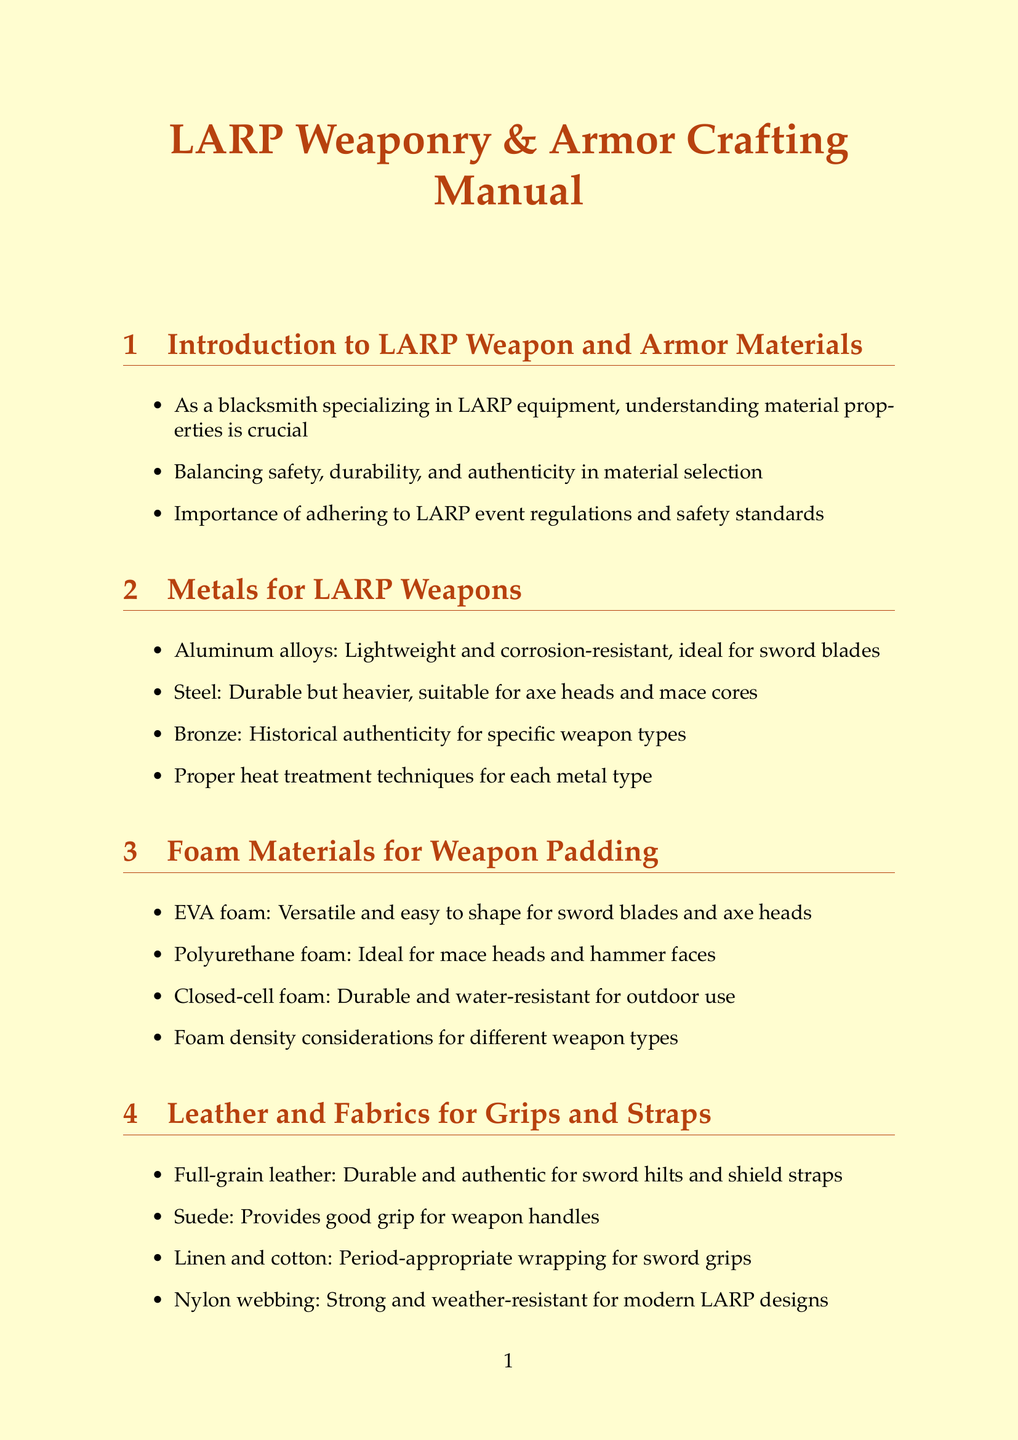What are the three key factors in material selection? The document lists safety, durability, and authenticity as crucial factors in material selection for LARP equipment.
Answer: safety, durability, authenticity Which foam material is ideal for mace heads? The document specifies polyurethane foam as the ideal material for mace heads and hammer faces.
Answer: polyurethane foam What is a traditional material for plate armor? The document mentions mild steel as a traditional material for plate armor.
Answer: mild steel What type of leather is recommended for sword hilts? The manual advises using full-grain leather for sword hilts and shield straps.
Answer: full-grain leather What technique is essential for steel armor? Rust-inhibiting primers are deemed essential for preventing rust in steel armor and weapon cores.
Answer: rust-inhibiting primers Which coating enhances appearance and provides water resistance for leather? The document notes the use of leather dyes and sealants for enhancing appearance and water resistance.
Answer: leather dyes and sealants What should be avoided in metal components? The manual emphasizes avoiding sharp edges and points in metal components for safety.
Answer: sharp edges and points What type of foam is durable and water-resistant? Closed-cell foam is highlighted as durable and water-resistant for outdoor use in the document.
Answer: closed-cell foam 